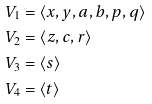<formula> <loc_0><loc_0><loc_500><loc_500>V _ { 1 } & = \langle x , y , a , b , p , q \rangle \\ V _ { 2 } & = \langle z , c , r \rangle \\ V _ { 3 } & = \langle s \rangle \\ V _ { 4 } & = \langle t \rangle \\</formula> 